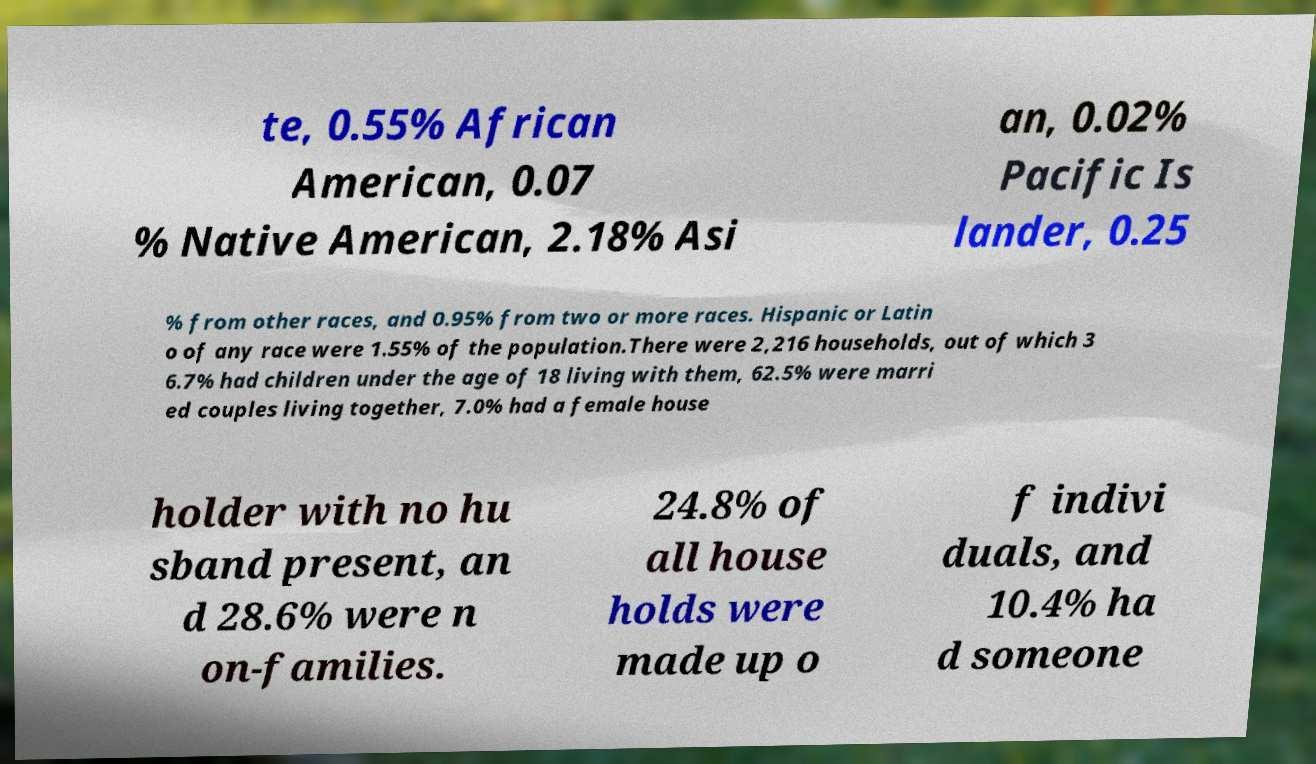I need the written content from this picture converted into text. Can you do that? te, 0.55% African American, 0.07 % Native American, 2.18% Asi an, 0.02% Pacific Is lander, 0.25 % from other races, and 0.95% from two or more races. Hispanic or Latin o of any race were 1.55% of the population.There were 2,216 households, out of which 3 6.7% had children under the age of 18 living with them, 62.5% were marri ed couples living together, 7.0% had a female house holder with no hu sband present, an d 28.6% were n on-families. 24.8% of all house holds were made up o f indivi duals, and 10.4% ha d someone 